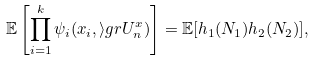Convert formula to latex. <formula><loc_0><loc_0><loc_500><loc_500>\mathbb { E } \left [ \prod _ { i = 1 } ^ { k } \psi _ { i } ( x _ { i } , \mathcal { i } g r { U } ^ { x } _ { n } ) \right ] = \mathbb { E } [ h _ { 1 } ( N _ { 1 } ) h _ { 2 } ( N _ { 2 } ) ] ,</formula> 